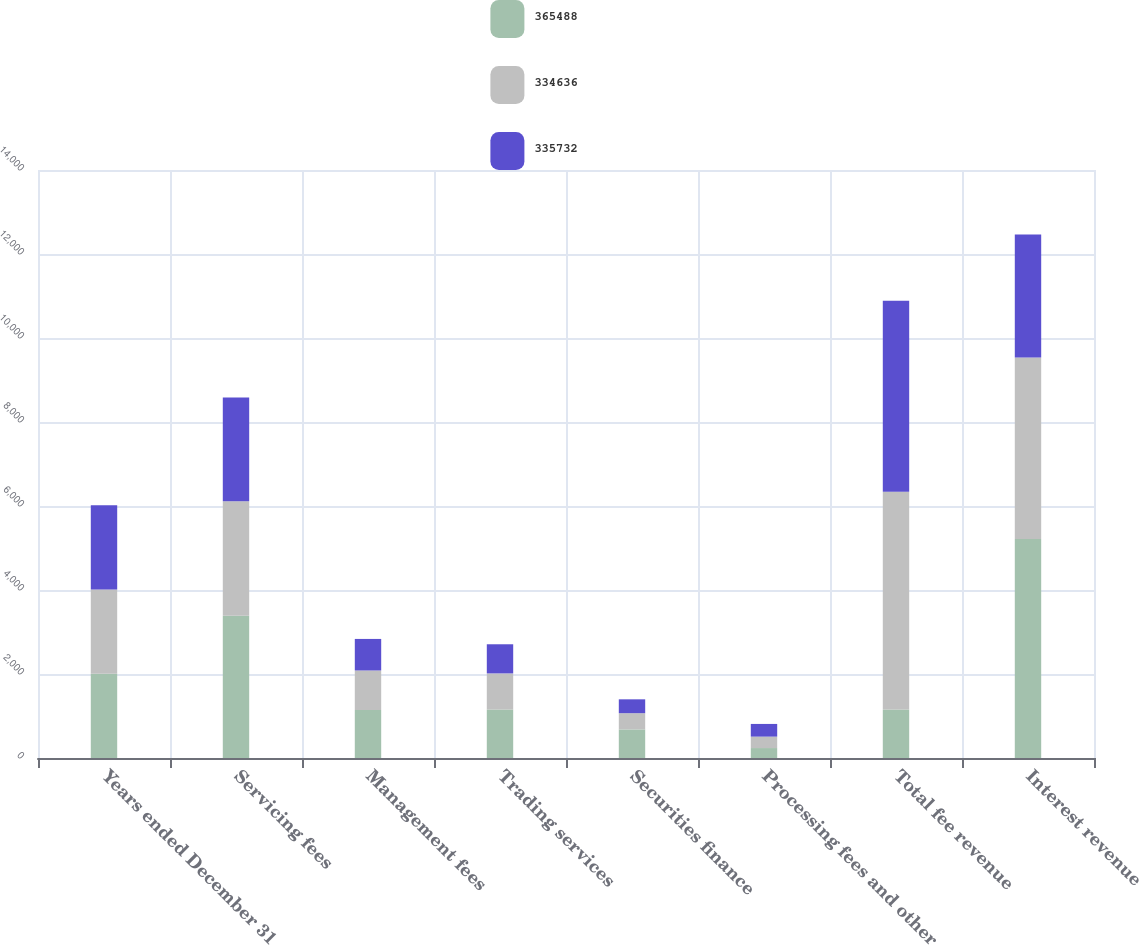Convert chart to OTSL. <chart><loc_0><loc_0><loc_500><loc_500><stacked_bar_chart><ecel><fcel>Years ended December 31<fcel>Servicing fees<fcel>Management fees<fcel>Trading services<fcel>Securities finance<fcel>Processing fees and other<fcel>Total fee revenue<fcel>Interest revenue<nl><fcel>365488<fcel>2007<fcel>3388<fcel>1141<fcel>1152<fcel>681<fcel>237<fcel>1152<fcel>5212<nl><fcel>334636<fcel>2006<fcel>2723<fcel>943<fcel>862<fcel>386<fcel>272<fcel>5186<fcel>4324<nl><fcel>335732<fcel>2005<fcel>2474<fcel>751<fcel>694<fcel>330<fcel>302<fcel>4551<fcel>2930<nl></chart> 